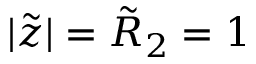<formula> <loc_0><loc_0><loc_500><loc_500>| \tilde { z } | = \tilde { R } _ { 2 } = 1</formula> 